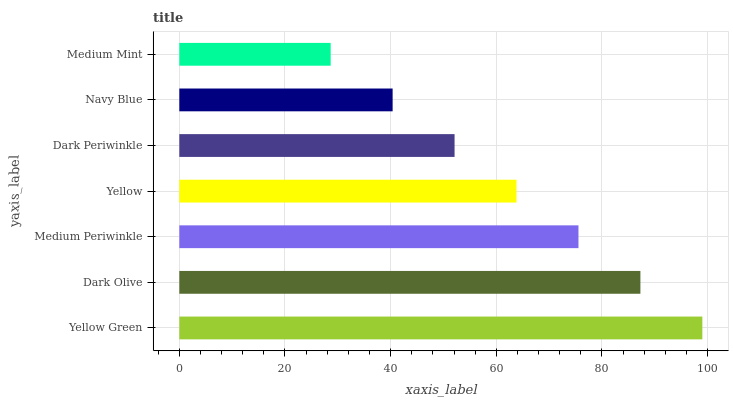Is Medium Mint the minimum?
Answer yes or no. Yes. Is Yellow Green the maximum?
Answer yes or no. Yes. Is Dark Olive the minimum?
Answer yes or no. No. Is Dark Olive the maximum?
Answer yes or no. No. Is Yellow Green greater than Dark Olive?
Answer yes or no. Yes. Is Dark Olive less than Yellow Green?
Answer yes or no. Yes. Is Dark Olive greater than Yellow Green?
Answer yes or no. No. Is Yellow Green less than Dark Olive?
Answer yes or no. No. Is Yellow the high median?
Answer yes or no. Yes. Is Yellow the low median?
Answer yes or no. Yes. Is Medium Mint the high median?
Answer yes or no. No. Is Dark Periwinkle the low median?
Answer yes or no. No. 